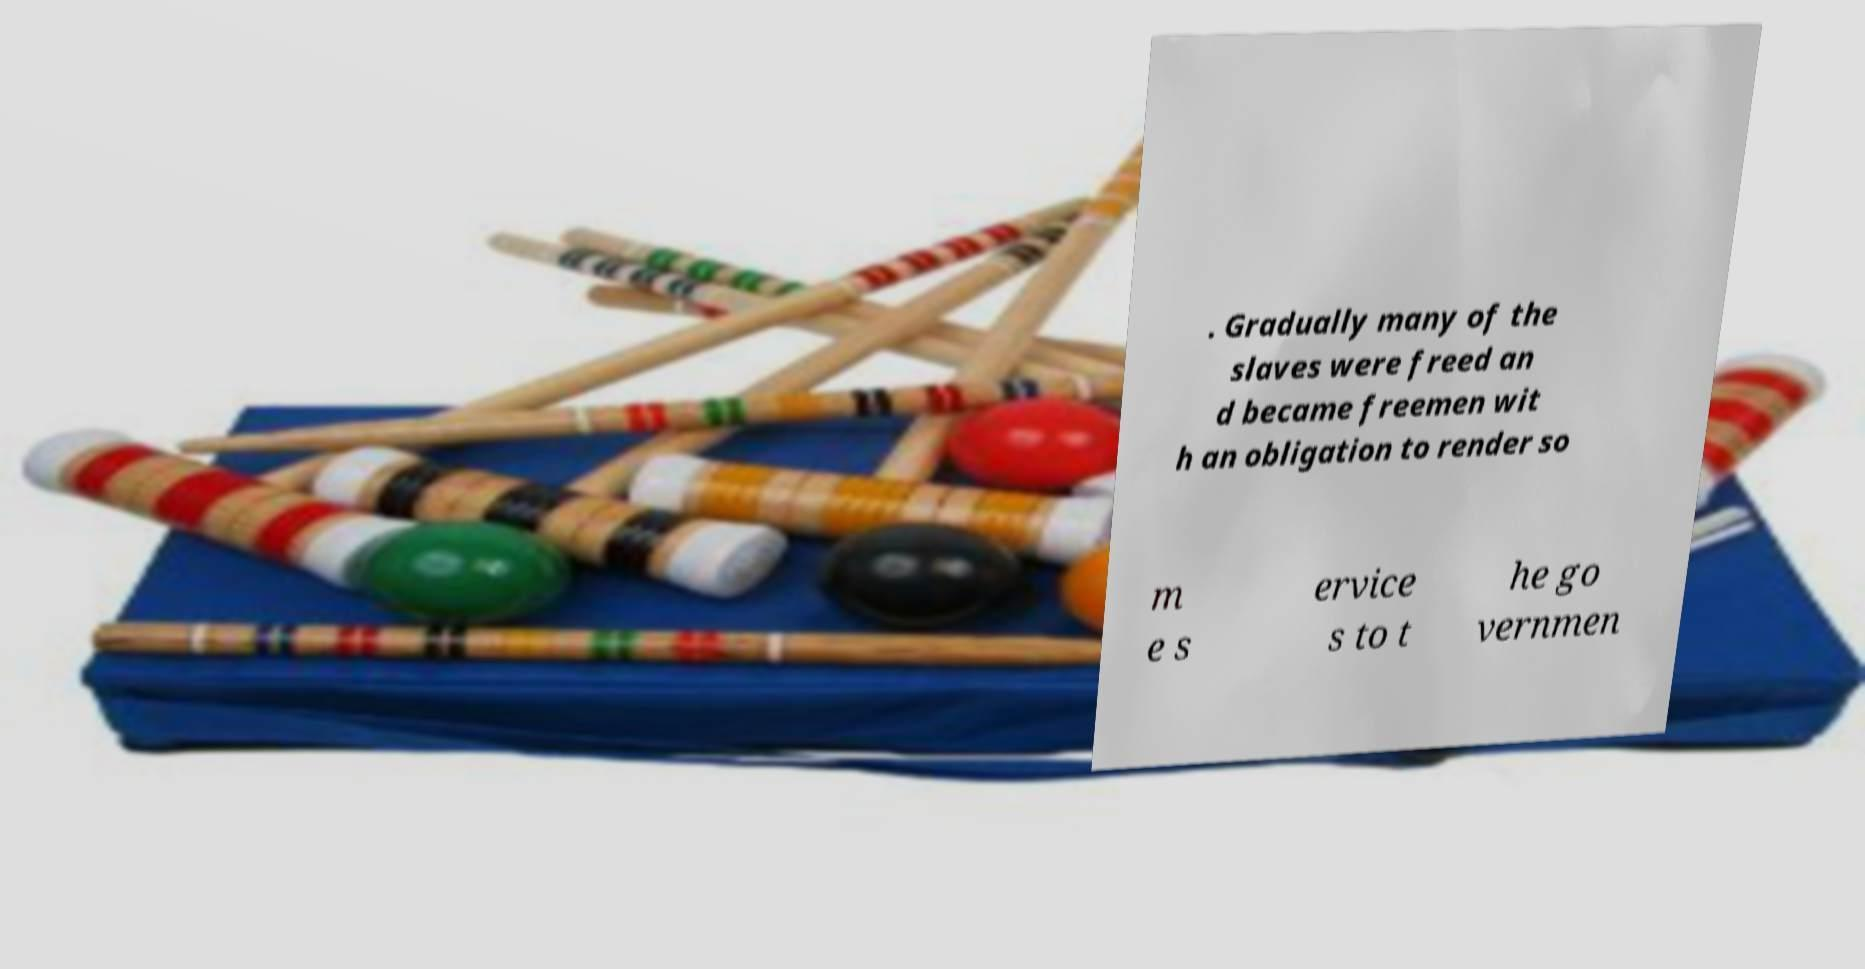Can you accurately transcribe the text from the provided image for me? . Gradually many of the slaves were freed an d became freemen wit h an obligation to render so m e s ervice s to t he go vernmen 